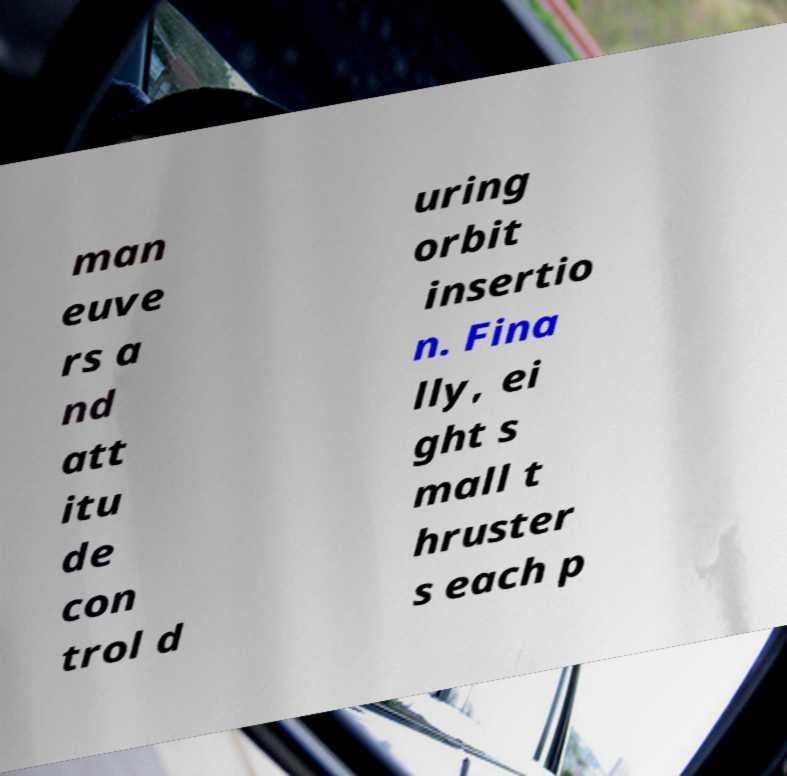Can you accurately transcribe the text from the provided image for me? man euve rs a nd att itu de con trol d uring orbit insertio n. Fina lly, ei ght s mall t hruster s each p 